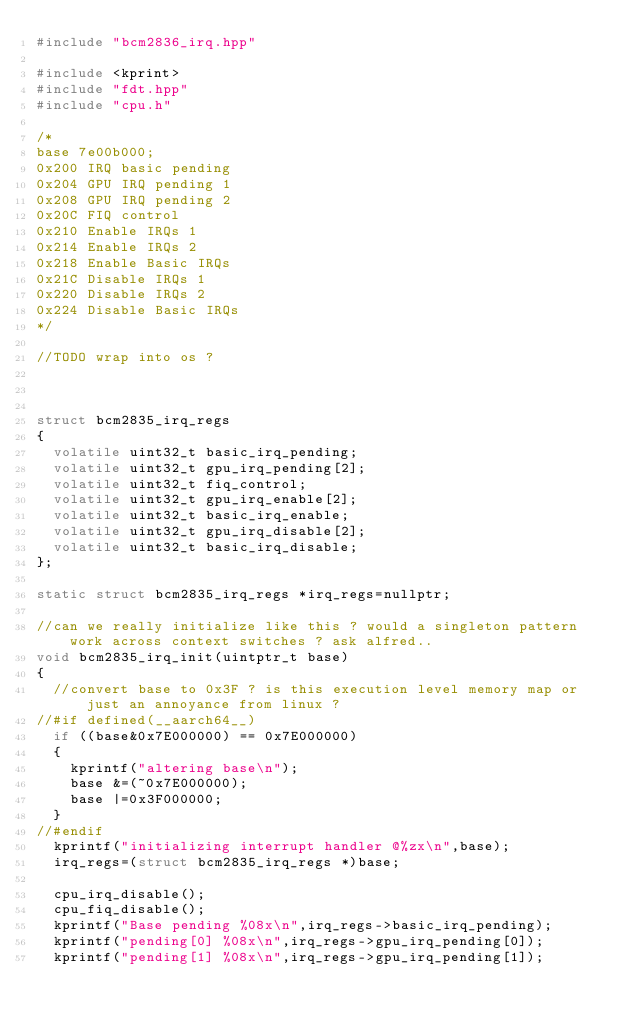<code> <loc_0><loc_0><loc_500><loc_500><_C++_>#include "bcm2836_irq.hpp"

#include <kprint>
#include "fdt.hpp"
#include "cpu.h"

/*
base 7e00b000;
0x200 IRQ basic pending
0x204 GPU IRQ pending 1
0x208 GPU IRQ pending 2
0x20C FIQ control
0x210 Enable IRQs 1
0x214 Enable IRQs 2
0x218 Enable Basic IRQs
0x21C Disable IRQs 1
0x220 Disable IRQs 2
0x224 Disable Basic IRQs
*/

//TODO wrap into os ?



struct bcm2835_irq_regs
{
  volatile uint32_t basic_irq_pending;
  volatile uint32_t gpu_irq_pending[2];
  volatile uint32_t fiq_control;
  volatile uint32_t gpu_irq_enable[2];
  volatile uint32_t basic_irq_enable;
  volatile uint32_t gpu_irq_disable[2];
  volatile uint32_t basic_irq_disable;
};

static struct bcm2835_irq_regs *irq_regs=nullptr;

//can we really initialize like this ? would a singleton pattern work across context switches ? ask alfred..
void bcm2835_irq_init(uintptr_t base)
{
  //convert base to 0x3F ? is this execution level memory map or just an annoyance from linux ?
//#if defined(__aarch64__)
  if ((base&0x7E000000) == 0x7E000000)
  {
    kprintf("altering base\n");
    base &=(~0x7E000000);
    base |=0x3F000000;
  }
//#endif
  kprintf("initializing interrupt handler @%zx\n",base);
  irq_regs=(struct bcm2835_irq_regs *)base;

  cpu_irq_disable();
  cpu_fiq_disable();
  kprintf("Base pending %08x\n",irq_regs->basic_irq_pending);
  kprintf("pending[0] %08x\n",irq_regs->gpu_irq_pending[0]);
  kprintf("pending[1] %08x\n",irq_regs->gpu_irq_pending[1]);</code> 